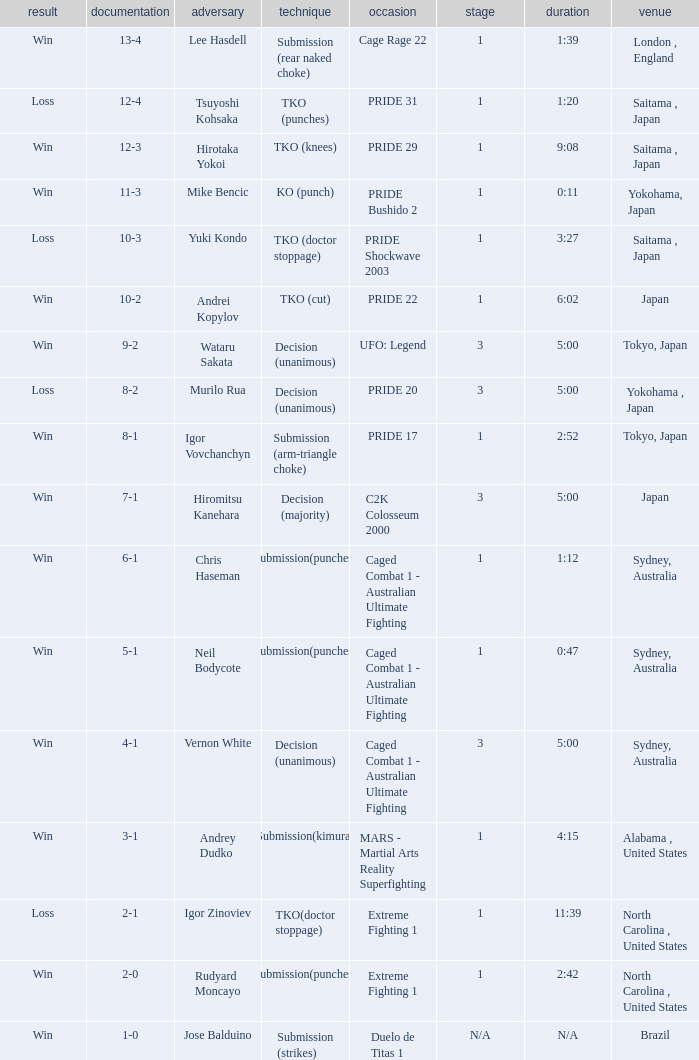Which Res has a Method of decision (unanimous) and an Opponent of Wataru Sakata? Win. 